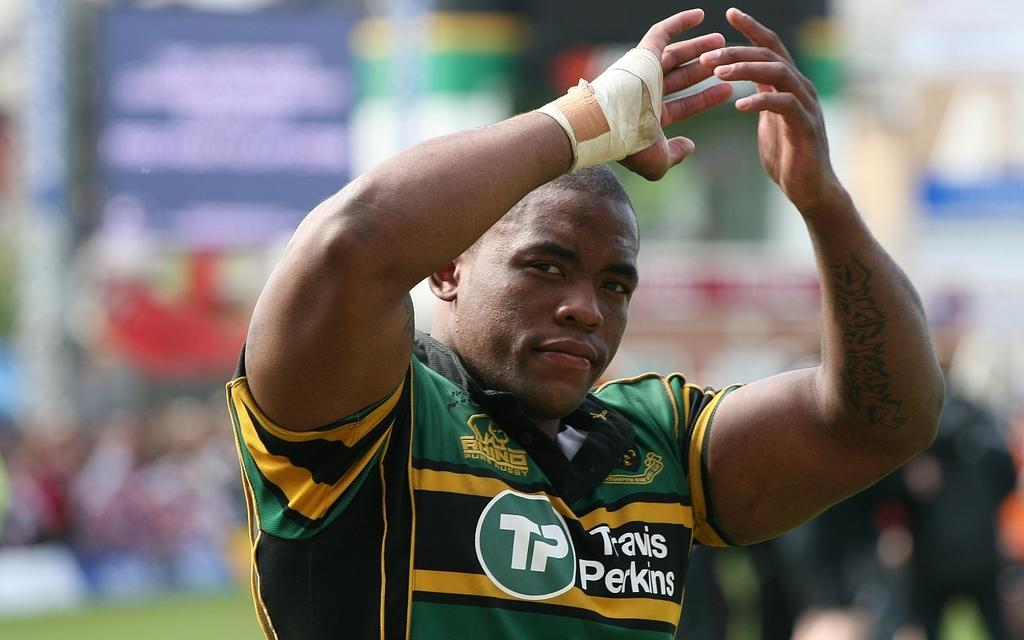<image>
Write a terse but informative summary of the picture. A sports athlete with the name Travis Perkins written on his jersey. 